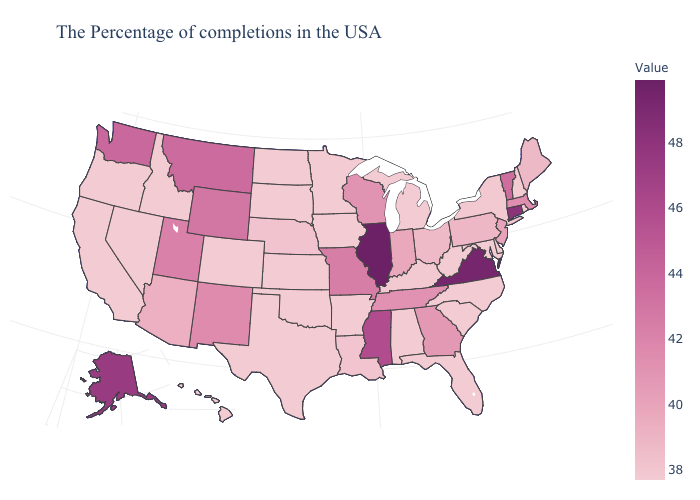Which states have the highest value in the USA?
Concise answer only. Illinois. Which states have the lowest value in the USA?
Write a very short answer. Rhode Island, New Hampshire, Delaware, Maryland, North Carolina, South Carolina, West Virginia, Florida, Michigan, Alabama, Arkansas, Minnesota, Iowa, Kansas, Oklahoma, Texas, South Dakota, North Dakota, Colorado, Idaho, Nevada, California, Oregon, Hawaii. Does Arizona have the highest value in the West?
Give a very brief answer. No. Does Arkansas have the highest value in the USA?
Short answer required. No. Does New Hampshire have the lowest value in the Northeast?
Concise answer only. Yes. 